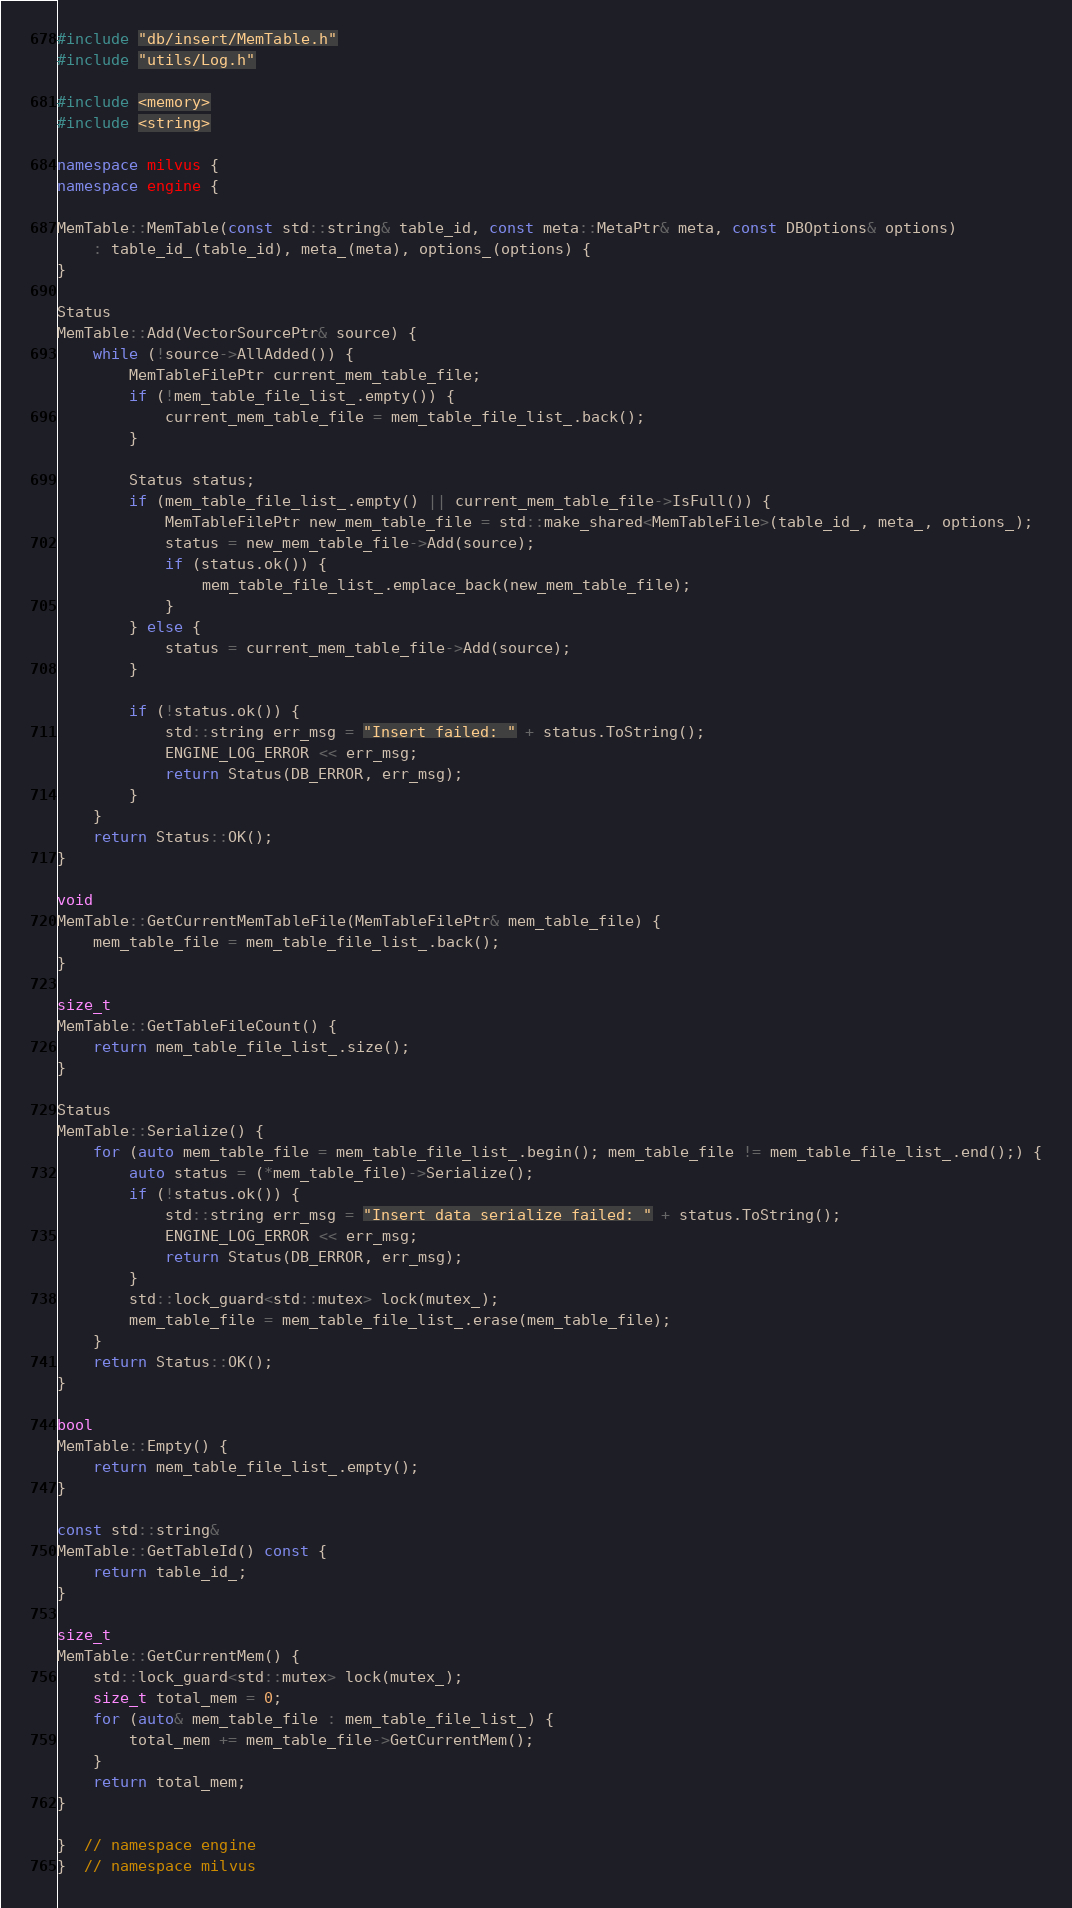Convert code to text. <code><loc_0><loc_0><loc_500><loc_500><_C++_>#include "db/insert/MemTable.h"
#include "utils/Log.h"

#include <memory>
#include <string>

namespace milvus {
namespace engine {

MemTable::MemTable(const std::string& table_id, const meta::MetaPtr& meta, const DBOptions& options)
    : table_id_(table_id), meta_(meta), options_(options) {
}

Status
MemTable::Add(VectorSourcePtr& source) {
    while (!source->AllAdded()) {
        MemTableFilePtr current_mem_table_file;
        if (!mem_table_file_list_.empty()) {
            current_mem_table_file = mem_table_file_list_.back();
        }

        Status status;
        if (mem_table_file_list_.empty() || current_mem_table_file->IsFull()) {
            MemTableFilePtr new_mem_table_file = std::make_shared<MemTableFile>(table_id_, meta_, options_);
            status = new_mem_table_file->Add(source);
            if (status.ok()) {
                mem_table_file_list_.emplace_back(new_mem_table_file);
            }
        } else {
            status = current_mem_table_file->Add(source);
        }

        if (!status.ok()) {
            std::string err_msg = "Insert failed: " + status.ToString();
            ENGINE_LOG_ERROR << err_msg;
            return Status(DB_ERROR, err_msg);
        }
    }
    return Status::OK();
}

void
MemTable::GetCurrentMemTableFile(MemTableFilePtr& mem_table_file) {
    mem_table_file = mem_table_file_list_.back();
}

size_t
MemTable::GetTableFileCount() {
    return mem_table_file_list_.size();
}

Status
MemTable::Serialize() {
    for (auto mem_table_file = mem_table_file_list_.begin(); mem_table_file != mem_table_file_list_.end();) {
        auto status = (*mem_table_file)->Serialize();
        if (!status.ok()) {
            std::string err_msg = "Insert data serialize failed: " + status.ToString();
            ENGINE_LOG_ERROR << err_msg;
            return Status(DB_ERROR, err_msg);
        }
        std::lock_guard<std::mutex> lock(mutex_);
        mem_table_file = mem_table_file_list_.erase(mem_table_file);
    }
    return Status::OK();
}

bool
MemTable::Empty() {
    return mem_table_file_list_.empty();
}

const std::string&
MemTable::GetTableId() const {
    return table_id_;
}

size_t
MemTable::GetCurrentMem() {
    std::lock_guard<std::mutex> lock(mutex_);
    size_t total_mem = 0;
    for (auto& mem_table_file : mem_table_file_list_) {
        total_mem += mem_table_file->GetCurrentMem();
    }
    return total_mem;
}

}  // namespace engine
}  // namespace milvus
</code> 